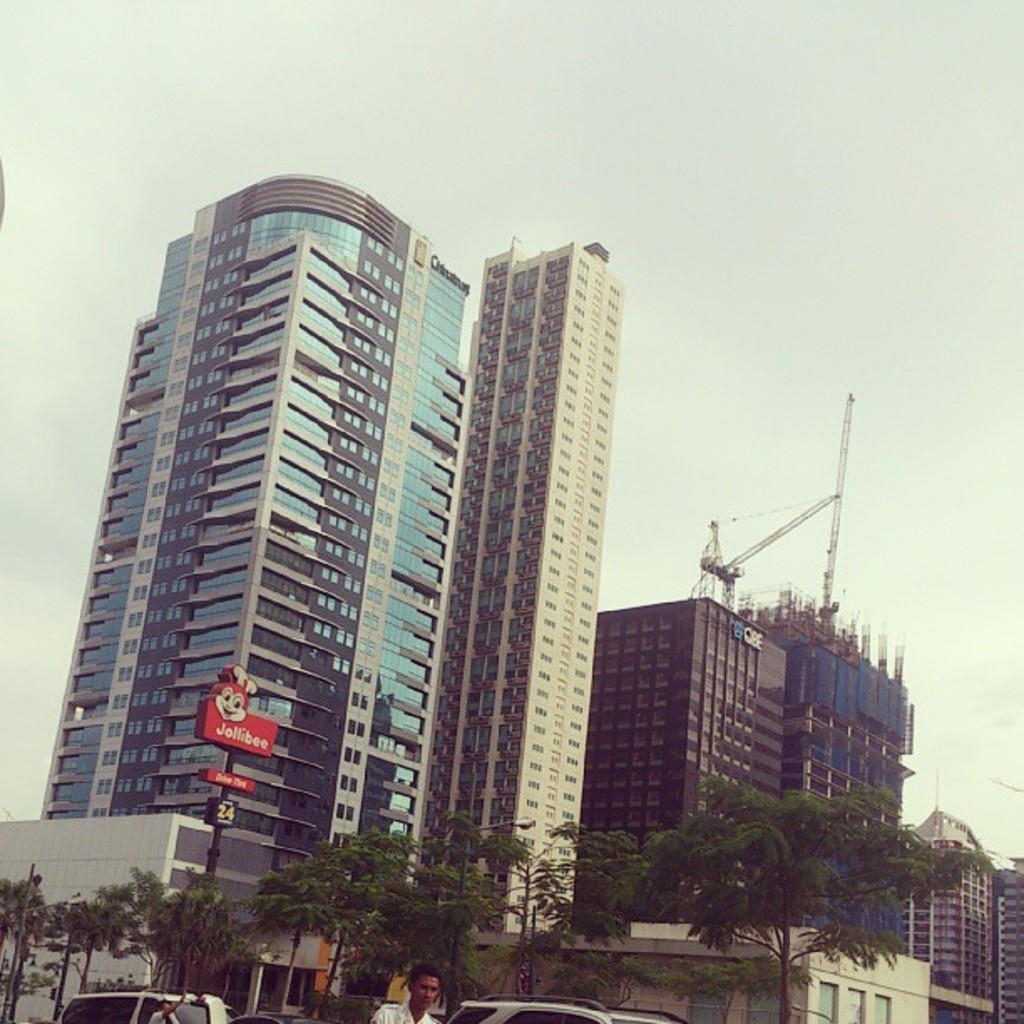Describe this image in one or two sentences. In this picture there is a skyscraper on the left side of the image and there are buildings on the right side of the image, there are trees at the bottom side of the image. 